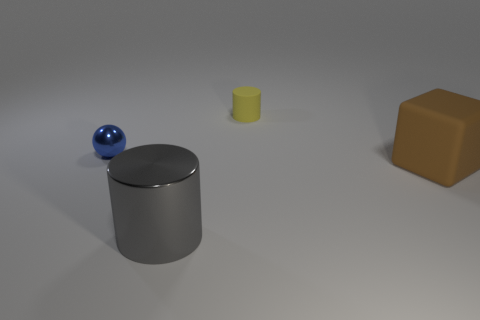Add 4 big rubber cubes. How many objects exist? 8 Subtract all yellow cylinders. How many cylinders are left? 1 Subtract all balls. How many objects are left? 3 Subtract all gray blocks. How many gray cylinders are left? 1 Subtract all tiny gray matte balls. Subtract all large matte cubes. How many objects are left? 3 Add 3 blocks. How many blocks are left? 4 Add 1 tiny blue metal things. How many tiny blue metal things exist? 2 Subtract 0 gray cubes. How many objects are left? 4 Subtract all purple cylinders. Subtract all yellow cubes. How many cylinders are left? 2 